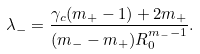Convert formula to latex. <formula><loc_0><loc_0><loc_500><loc_500>\lambda _ { - } = \frac { \gamma _ { c } ( m _ { + } - 1 ) + 2 m _ { + } } { ( m _ { - } - m _ { + } ) R _ { 0 } ^ { m _ { - } - 1 } } .</formula> 